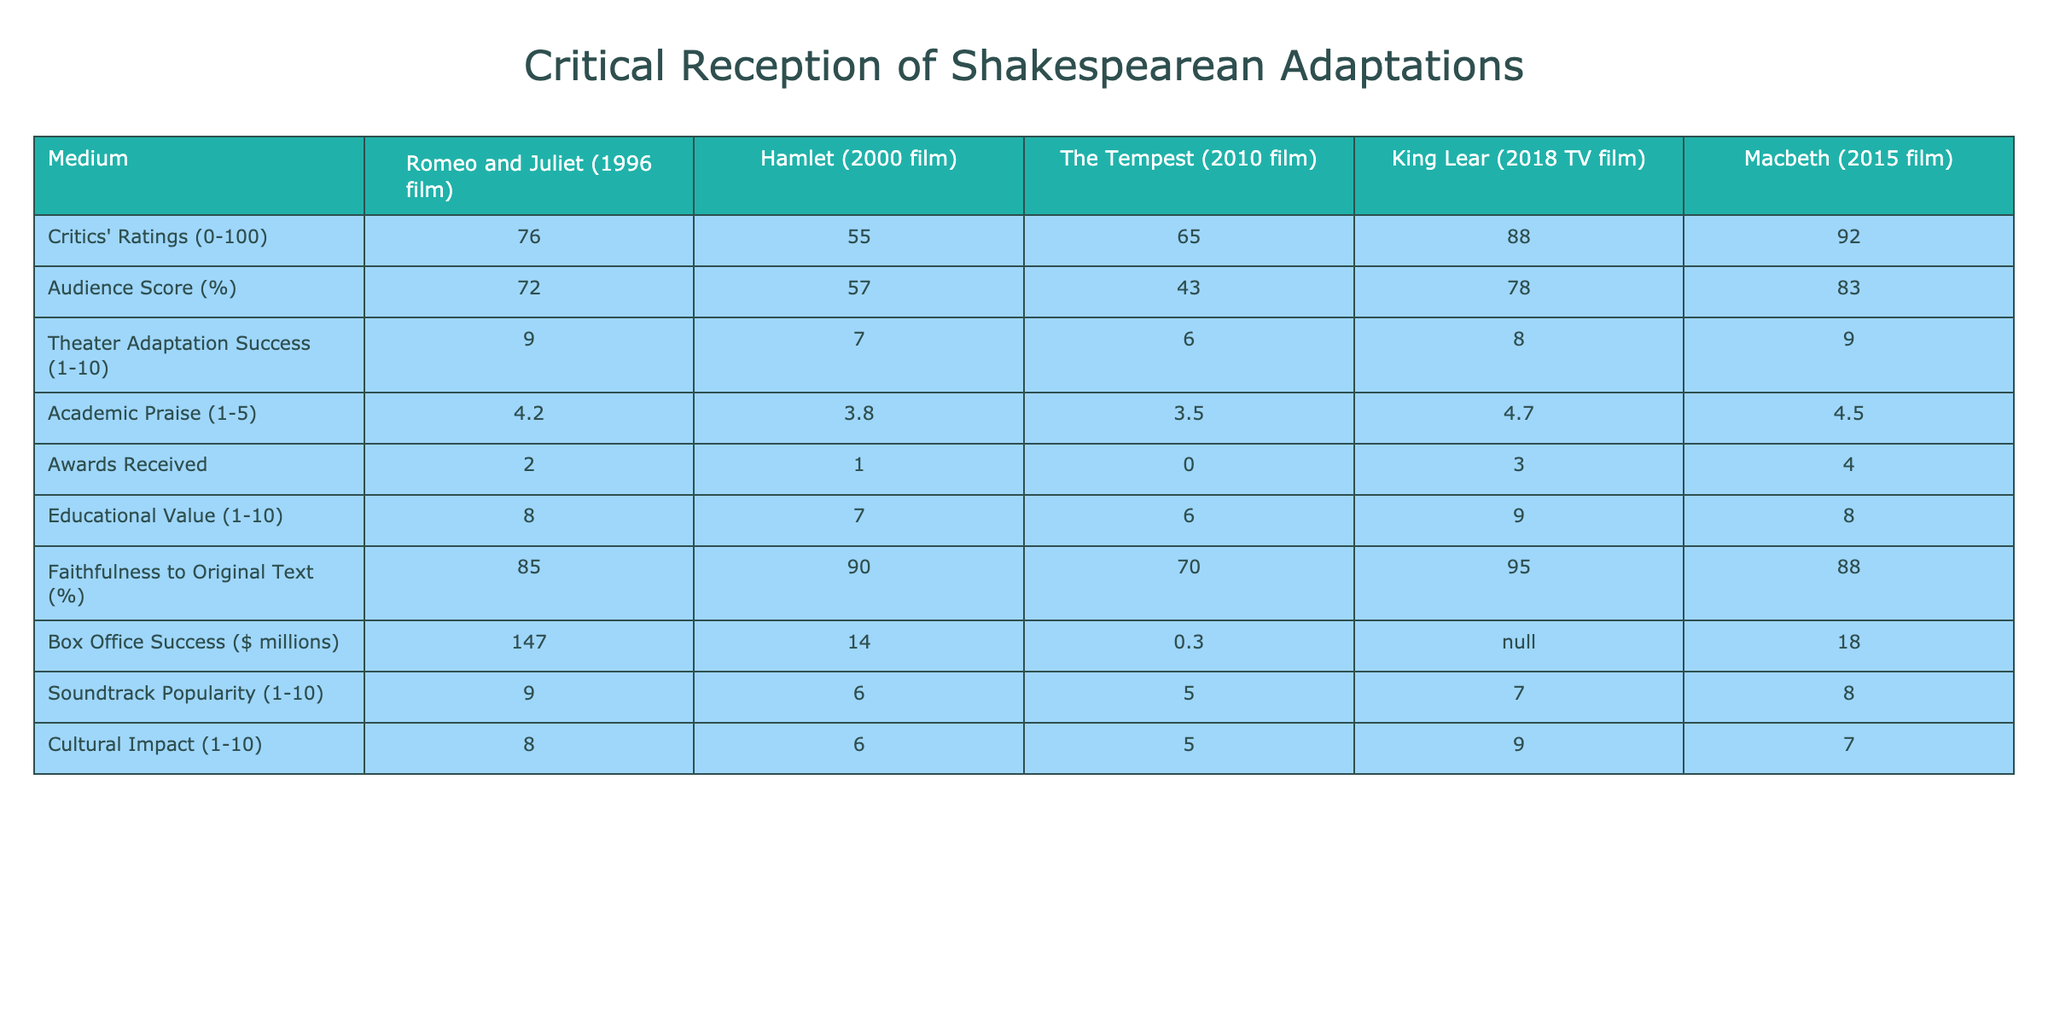What is the critics' rating for "King Lear" (2018 TV film)? The critics' rating is provided directly in the table under the "Critics' Ratings" row for "King Lear" (2018 TV film), which shows a score of 88.
Answer: 88 What is the audience score for "The Tempest" (2010 film)? The audience score for "The Tempest" (2010 film) is presented in the "Audience Score (%)" row, and it indicates a score of 43.
Answer: 43 Which adaptation received the most awards? We compare the "Awards Received" column for each adaptation and find that "Macbeth" (2015 film) received 4 awards, which is the highest.
Answer: Macbeth (2015 film) What is the average educational value of all adaptations? The educational values are 8, 7, 6, 9, and 8 for the adaptations. We sum these values: (8 + 7 + 6 + 9 + 8) = 38, and then divide by 5 (the number of adaptations): 38 / 5 = 7.6.
Answer: 7.6 Is the cultural impact of "Romeo and Juliet" (1996 film) higher than that of "Hamlet" (2000 film)? We compare the "Cultural Impact" scores: "Romeo and Juliet" (1996 film) has a score of 8, while "Hamlet" (2000 film) has a score of 6. Since 8 is greater than 6, the statement is true.
Answer: Yes What is the difference in box office success between "Romeo and Juliet" (1996 film) and "Hamlet" (2000 film)? The box office success figures are $147 million for "Romeo and Juliet" and $14 million for "Hamlet." The difference is calculated as 147 - 14 = 133 million dollars.
Answer: 133 million Which adaptation has the highest faithfulness to the original text? By examining the "Faithfulness to Original Text (%)" row, "King Lear" (2018 TV film) has the highest percentage at 95%.
Answer: King Lear (2018 TV film) If we consider only the adaptations with an awards count of 3 or more, what is the average critics' rating for those adaptations? The adaptations with 3 or more awards are "King Lear" (3 awards) and "Macbeth" (4 awards) with critics' ratings of 88 and 92, respectively. The average is calculated as (88 + 92) / 2 = 90.
Answer: 90 How many adaptations have an audience score below 60%? We check the "Audience Score (%)" row and see that both "Hamlet" and "The Tempest" have scores of 57 and 43, respectively, which are below 60%. Therefore, the count is 2.
Answer: 2 Which adaptation has both the highest critics' rating and highest audience score? We look at the table and find that "Macbeth" has the highest critics' rating of 92, but its audience score is 83, which is less than "King Lear," with 88 critics' rating and 78 audience score. Thus, "Macbeth" scores highest for critics, and "King Lear" has the highest audience score among the top.
Answer: Macbeth (for critics), King Lear (for audience) 